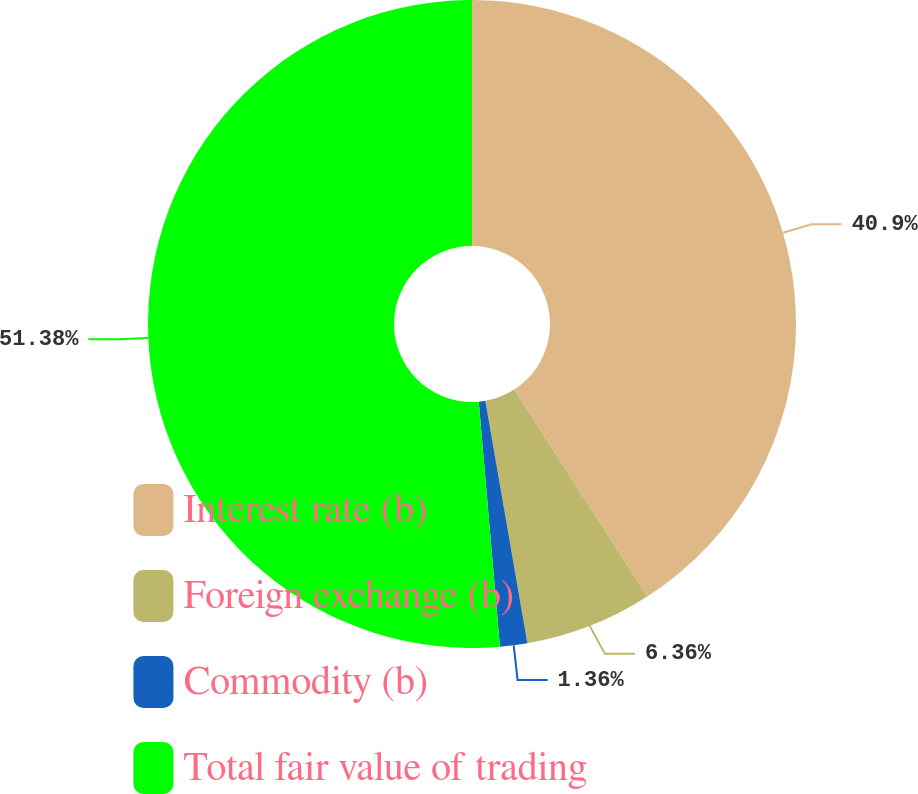Convert chart. <chart><loc_0><loc_0><loc_500><loc_500><pie_chart><fcel>Interest rate (b)<fcel>Foreign exchange (b)<fcel>Commodity (b)<fcel>Total fair value of trading<nl><fcel>40.9%<fcel>6.36%<fcel>1.36%<fcel>51.37%<nl></chart> 